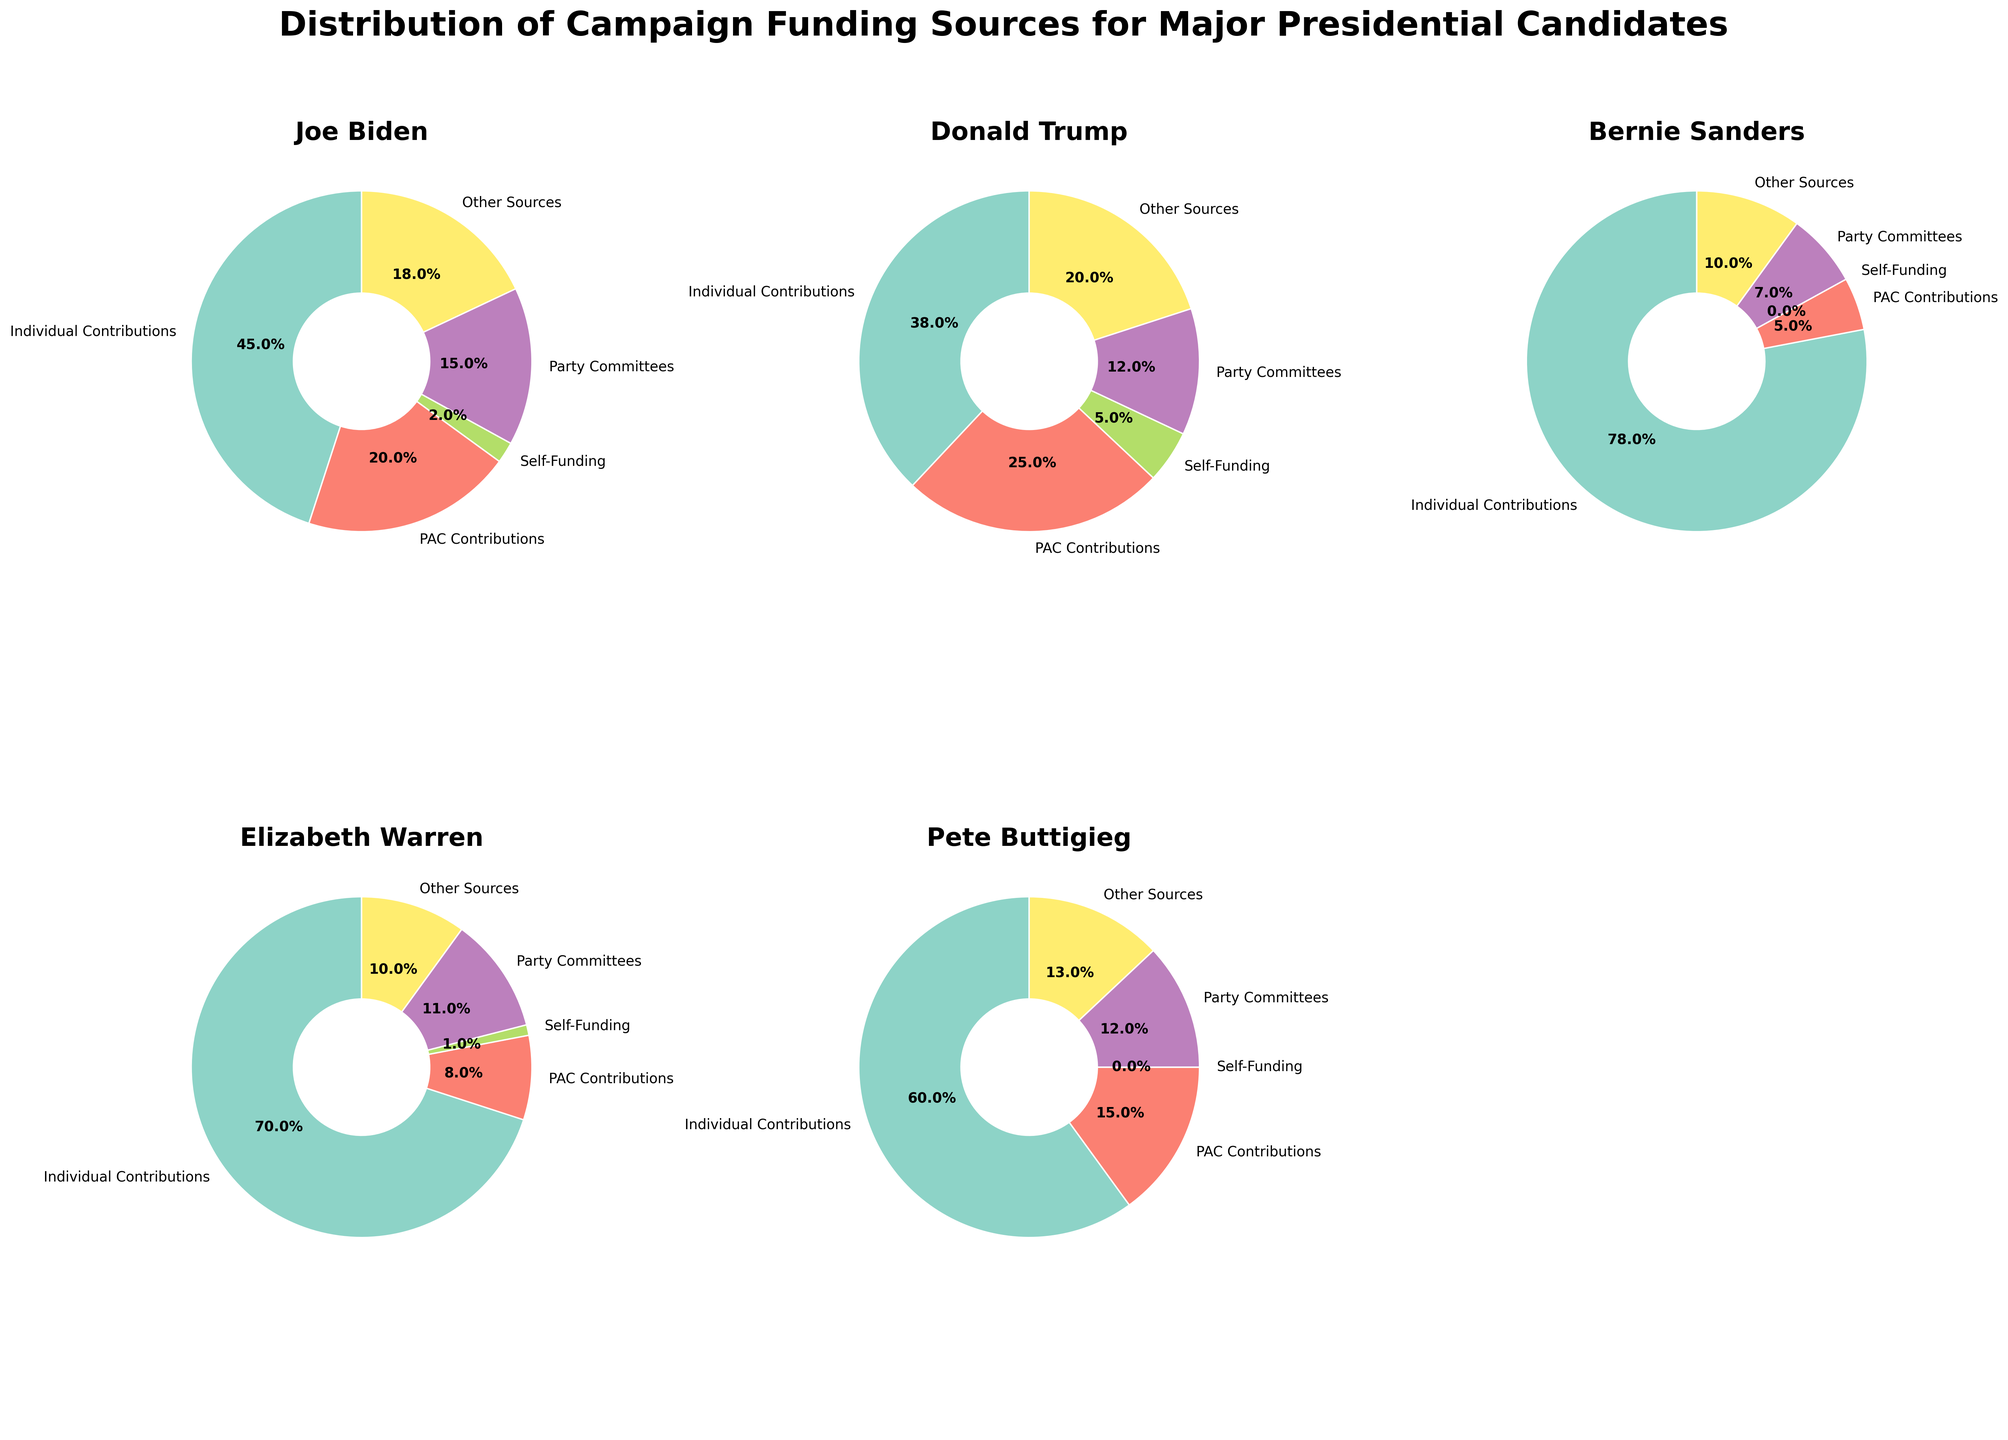What's the total percentage of campaign funding that Joe Biden received from Party Committees and Other Sources? Joe Biden's funding from Party Committees is 15%, and from Other Sources is 18%. Sum these percentages: 15% + 18% = 33%
Answer: 33% Which candidate received the highest percentage of Individual Contributions? Looking at the pie chart slices for Individual Contributions across all candidates, Bernie Sanders has the largest slice at 78%
Answer: Bernie Sanders How does the percentage of PAC Contributions for Donald Trump compare to Joe Biden? Donald Trump's PAC Contributions are 25%, while Joe Biden's PAC Contributions are 20%. 25% is greater than 20%
Answer: Donald Trump's PAC Contributions are higher Which funding source has the smallest contribution for Elizabeth Warren? Looking at Elizabeth Warren's pie chart, the smallest slice is Self-Funding, which is 1%
Answer: Self-Funding What is the difference in the percentage of Self-Funding between Joe Biden and Donald Trump? Joe Biden's Self-Funding is 2% and Donald Trump's Self-Funding is 5%. The difference is 5% - 2% = 3%
Answer: 3% Among all the candidates, who has the least percentage of Self-Funding? By examining each candidate's chart for Self-Funding, Bernie Sanders and Pete Buttigieg both have 0%
Answer: Bernie Sanders and Pete Buttigieg Compare the percentages of Individual Contributions for Pete Buttigieg and Elizabeth Warren. Pete Buttigieg has 60% in Individual Contributions while Elizabeth Warren has 70%. 70% is greater than 60%
Answer: Elizabeth Warren's Individual Contributions are higher What percentage of campaign funding for Bernie Sanders comes from Party Committees and PAC Contributions combined? Bernie Sanders receives 7% from Party Committees and 5% from PAC Contributions. Sum these percentages: 7% + 5% = 12%
Answer: 12% Which candidate has the highest percentage of funding from Other Sources? Looking at the Other Sources slices for each candidate, Donald Trump has the highest at 20%
Answer: Donald Trump 